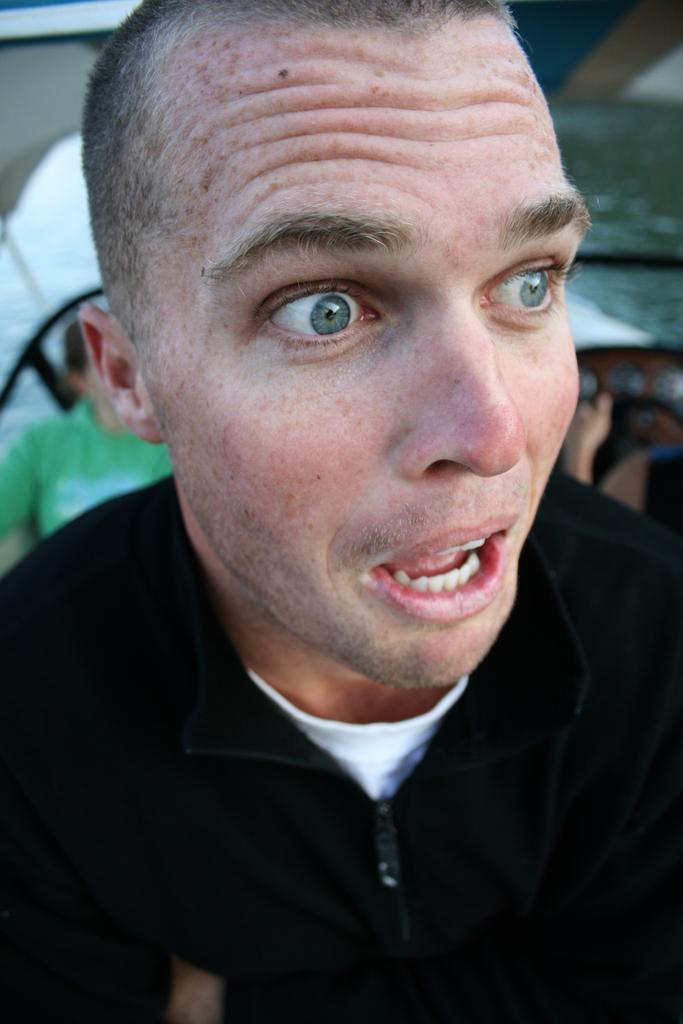How would you summarize this image in a sentence or two? In this picture there is a man wearing black jacket. The background is blurred. In the background there is a ship in the water. On the left there is a person in green t-shirt. On the right there is another person. 